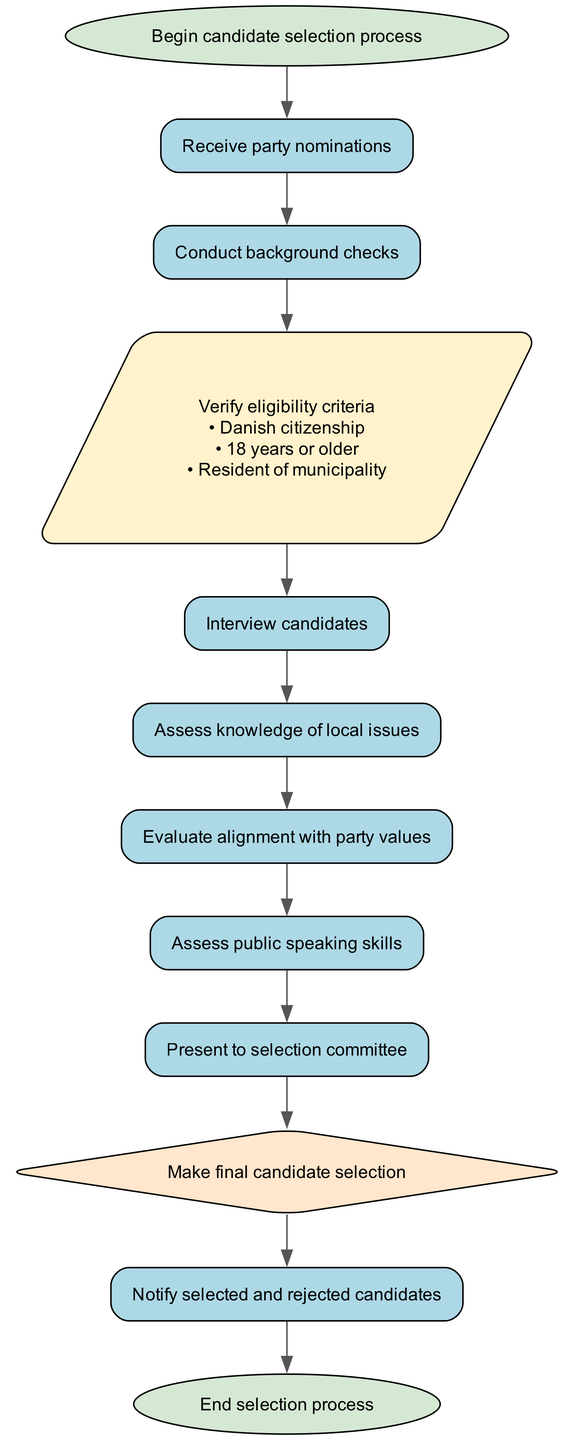What is the first step in the candidate selection process? The first step in the diagram is indicated by the node "start," which states "Begin candidate selection process."
Answer: Begin candidate selection process How many conditions are verified in the eligibility step? The "eligibility" node lists three conditions: Danish citizenship, 18 years or older, and resident of municipality. Therefore, the total count of conditions is three.
Answer: 3 Which node represents the assessment of public speaking skills? The node labeled "public_speaking" specifically mentions the assessment of public speaking skills as part of the flowchart.
Answer: Assess public speaking skills What is the last step before notification of candidates? The last step before notifying candidates is the "final_decision" node, which indicates making the final candidate selection.
Answer: Make final candidate selection Which shape is used to represent the eligibility verification node? The eligibility verification step is represented using a parallelogram shape, which is described in the diagram as specific to this node.
Answer: Parallelogram What must candidates be before they can be interviewed? Candidates must pass eligibility verification before proceeding to the interview stage, as indicated by the flow from the "eligibility" node to the "interview" node.
Answer: Verified Which step follows the assessment of knowledge of local issues? The step that follows the assessment of knowledge of local issues is evaluating alignment with party values, as outlined in the connection from "local_issues" to "party_alignment."
Answer: Evaluate alignment with party values How many total nodes are present in the diagram? By counting the distinct elements in the provided diagram, there are 12 nodes in total.
Answer: 12 What type of node is used for the final decision step? The final decision step is represented as a diamond shape, which signifies a decision point in the flowchart.
Answer: Diamond 